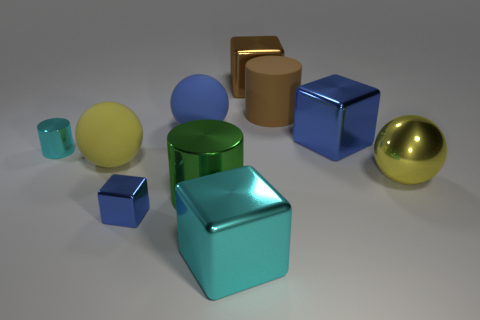Is the color of the tiny cylinder the same as the big object in front of the large metallic cylinder?
Keep it short and to the point. Yes. Is the color of the large metallic block in front of the shiny sphere the same as the tiny metallic cylinder?
Give a very brief answer. Yes. What number of objects are either large blue metallic cylinders or blue spheres that are behind the green metallic object?
Your answer should be compact. 1. The large object that is behind the large blue shiny cube and on the left side of the big cyan thing is made of what material?
Your response must be concise. Rubber. There is a big yellow thing that is to the right of the blue rubber ball; what is it made of?
Ensure brevity in your answer.  Metal. What color is the tiny cylinder that is the same material as the large green cylinder?
Offer a terse response. Cyan. There is a large yellow rubber object; is it the same shape as the cyan metal thing behind the cyan metallic block?
Offer a very short reply. No. Are there any matte spheres on the left side of the large brown metal thing?
Make the answer very short. Yes. There is another ball that is the same color as the metal sphere; what is its material?
Offer a terse response. Rubber. There is a cyan block; is it the same size as the metal cylinder that is in front of the metallic sphere?
Ensure brevity in your answer.  Yes. 